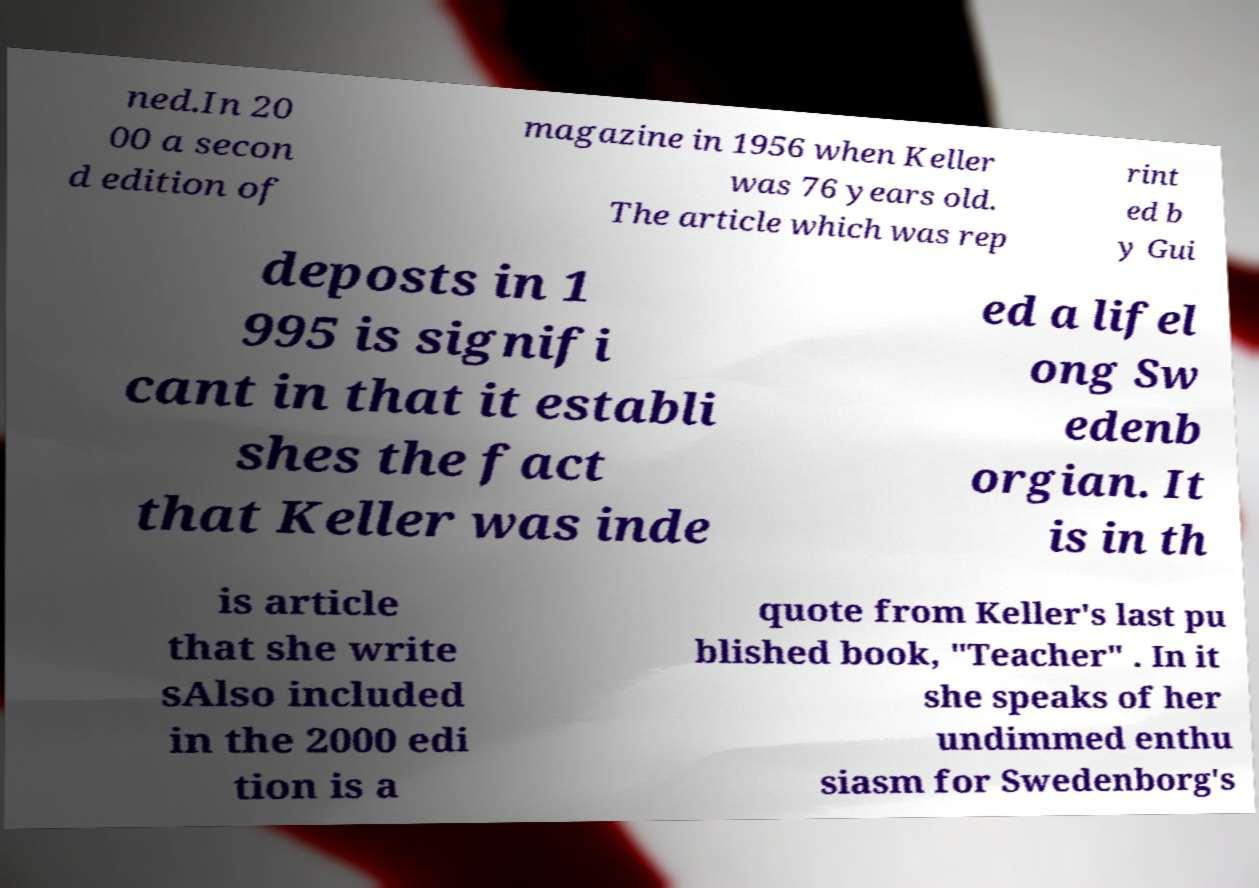Can you read and provide the text displayed in the image?This photo seems to have some interesting text. Can you extract and type it out for me? ned.In 20 00 a secon d edition of magazine in 1956 when Keller was 76 years old. The article which was rep rint ed b y Gui deposts in 1 995 is signifi cant in that it establi shes the fact that Keller was inde ed a lifel ong Sw edenb orgian. It is in th is article that she write sAlso included in the 2000 edi tion is a quote from Keller's last pu blished book, "Teacher" . In it she speaks of her undimmed enthu siasm for Swedenborg's 